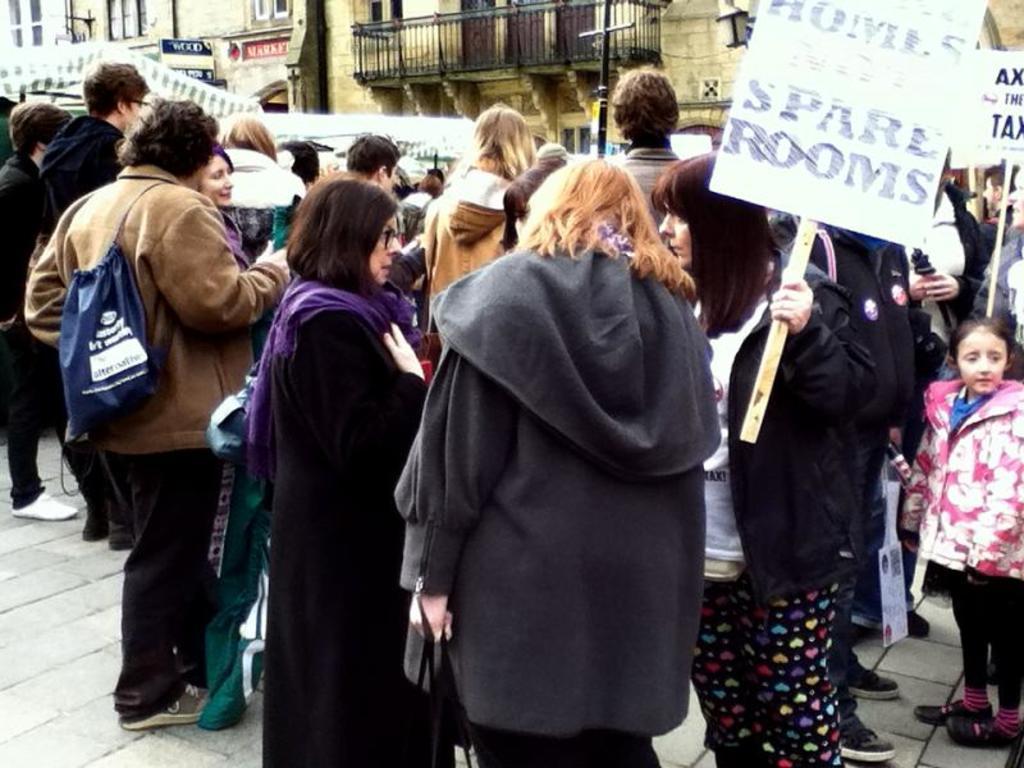In one or two sentences, can you explain what this image depicts? In this picture we can observe some people standing. There are men and women in this picture. One of the woman is holding a stick to which a board is fixed, in her hand. In the background there are buildings. 